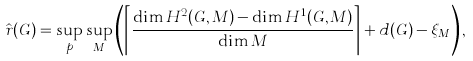Convert formula to latex. <formula><loc_0><loc_0><loc_500><loc_500>\hat { r } ( G ) = \sup _ { p } \sup _ { M } \left ( \left \lceil \frac { \dim H ^ { 2 } ( G , M ) - \dim H ^ { 1 } ( G , M ) } { \dim M } \right \rceil + d ( G ) - \xi _ { M } \right ) ,</formula> 